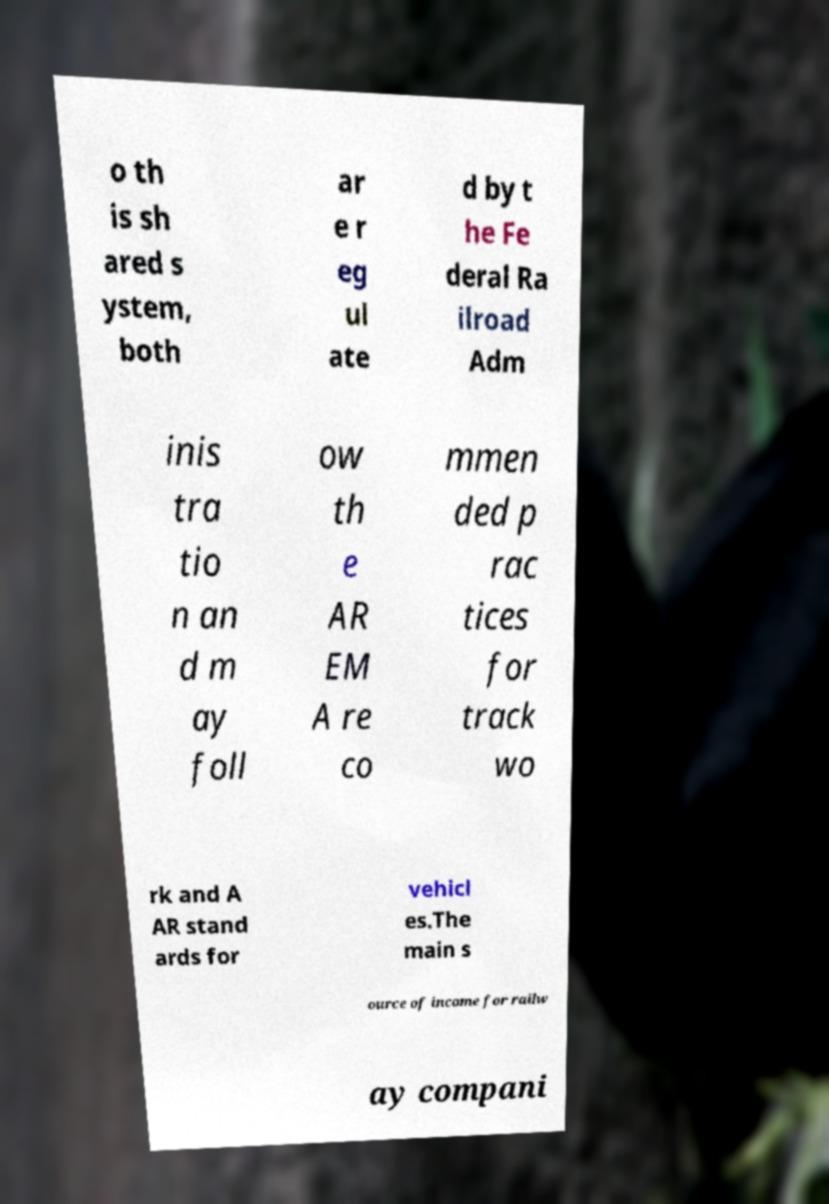For documentation purposes, I need the text within this image transcribed. Could you provide that? o th is sh ared s ystem, both ar e r eg ul ate d by t he Fe deral Ra ilroad Adm inis tra tio n an d m ay foll ow th e AR EM A re co mmen ded p rac tices for track wo rk and A AR stand ards for vehicl es.The main s ource of income for railw ay compani 